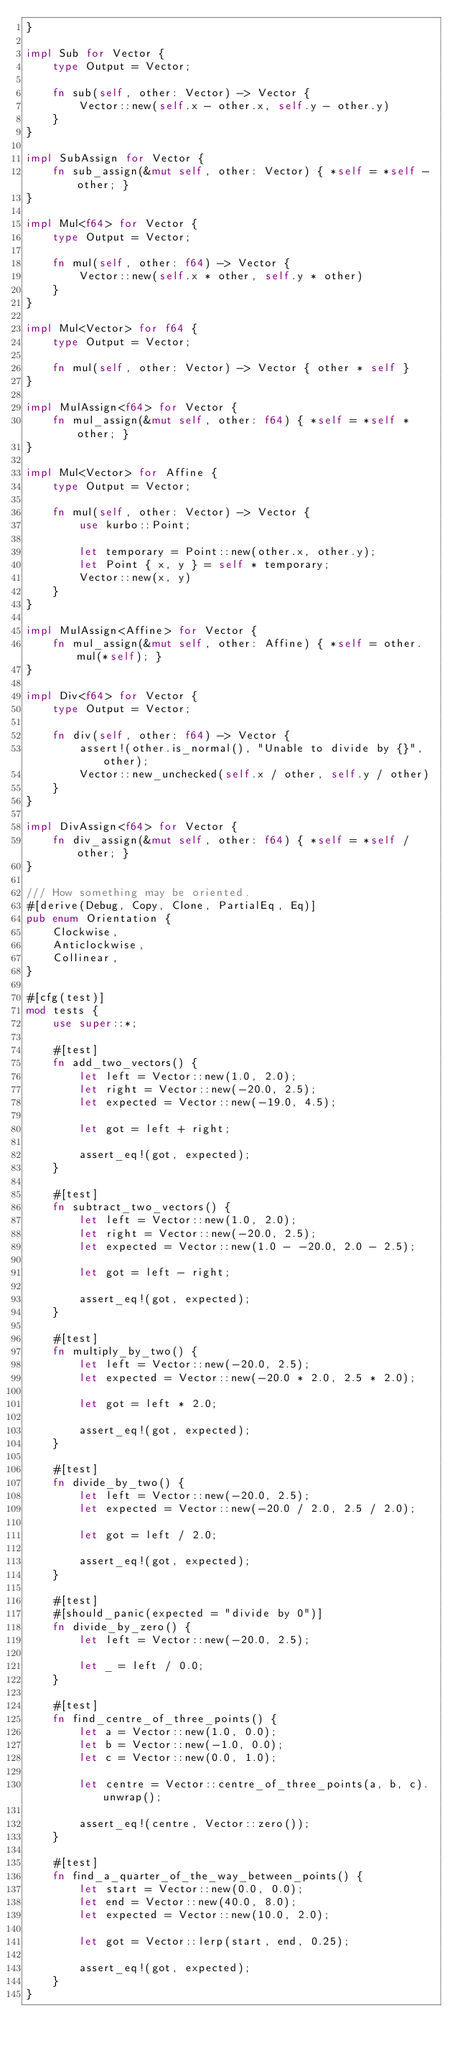Convert code to text. <code><loc_0><loc_0><loc_500><loc_500><_Rust_>}

impl Sub for Vector {
    type Output = Vector;

    fn sub(self, other: Vector) -> Vector {
        Vector::new(self.x - other.x, self.y - other.y)
    }
}

impl SubAssign for Vector {
    fn sub_assign(&mut self, other: Vector) { *self = *self - other; }
}

impl Mul<f64> for Vector {
    type Output = Vector;

    fn mul(self, other: f64) -> Vector {
        Vector::new(self.x * other, self.y * other)
    }
}

impl Mul<Vector> for f64 {
    type Output = Vector;

    fn mul(self, other: Vector) -> Vector { other * self }
}

impl MulAssign<f64> for Vector {
    fn mul_assign(&mut self, other: f64) { *self = *self * other; }
}

impl Mul<Vector> for Affine {
    type Output = Vector;

    fn mul(self, other: Vector) -> Vector {
        use kurbo::Point;

        let temporary = Point::new(other.x, other.y);
        let Point { x, y } = self * temporary;
        Vector::new(x, y)
    }
}

impl MulAssign<Affine> for Vector {
    fn mul_assign(&mut self, other: Affine) { *self = other.mul(*self); }
}

impl Div<f64> for Vector {
    type Output = Vector;

    fn div(self, other: f64) -> Vector {
        assert!(other.is_normal(), "Unable to divide by {}", other);
        Vector::new_unchecked(self.x / other, self.y / other)
    }
}

impl DivAssign<f64> for Vector {
    fn div_assign(&mut self, other: f64) { *self = *self / other; }
}

/// How something may be oriented.
#[derive(Debug, Copy, Clone, PartialEq, Eq)]
pub enum Orientation {
    Clockwise,
    Anticlockwise,
    Collinear,
}

#[cfg(test)]
mod tests {
    use super::*;

    #[test]
    fn add_two_vectors() {
        let left = Vector::new(1.0, 2.0);
        let right = Vector::new(-20.0, 2.5);
        let expected = Vector::new(-19.0, 4.5);

        let got = left + right;

        assert_eq!(got, expected);
    }

    #[test]
    fn subtract_two_vectors() {
        let left = Vector::new(1.0, 2.0);
        let right = Vector::new(-20.0, 2.5);
        let expected = Vector::new(1.0 - -20.0, 2.0 - 2.5);

        let got = left - right;

        assert_eq!(got, expected);
    }

    #[test]
    fn multiply_by_two() {
        let left = Vector::new(-20.0, 2.5);
        let expected = Vector::new(-20.0 * 2.0, 2.5 * 2.0);

        let got = left * 2.0;

        assert_eq!(got, expected);
    }

    #[test]
    fn divide_by_two() {
        let left = Vector::new(-20.0, 2.5);
        let expected = Vector::new(-20.0 / 2.0, 2.5 / 2.0);

        let got = left / 2.0;

        assert_eq!(got, expected);
    }

    #[test]
    #[should_panic(expected = "divide by 0")]
    fn divide_by_zero() {
        let left = Vector::new(-20.0, 2.5);

        let _ = left / 0.0;
    }

    #[test]
    fn find_centre_of_three_points() {
        let a = Vector::new(1.0, 0.0);
        let b = Vector::new(-1.0, 0.0);
        let c = Vector::new(0.0, 1.0);

        let centre = Vector::centre_of_three_points(a, b, c).unwrap();

        assert_eq!(centre, Vector::zero());
    }

    #[test]
    fn find_a_quarter_of_the_way_between_points() {
        let start = Vector::new(0.0, 0.0);
        let end = Vector::new(40.0, 8.0);
        let expected = Vector::new(10.0, 2.0);

        let got = Vector::lerp(start, end, 0.25);

        assert_eq!(got, expected);
    }
}
</code> 